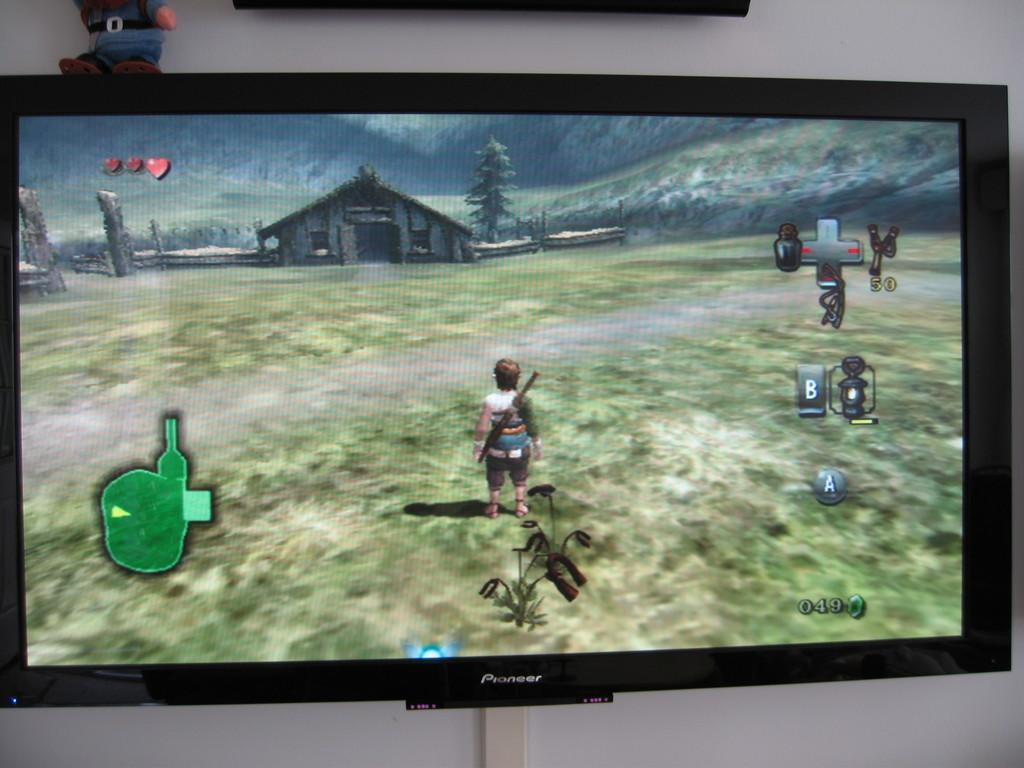Provide a one-sentence caption for the provided image. Someone playing a Legend of Zelda game on a Pioneer television. 